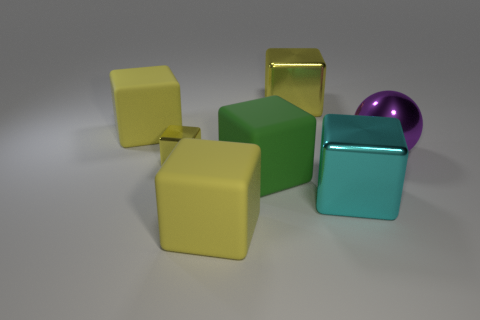How many yellow cubes must be subtracted to get 2 yellow cubes? 2 Subtract all big green matte cubes. How many cubes are left? 5 Add 2 small metallic cubes. How many objects exist? 9 Subtract 1 cubes. How many cubes are left? 5 Subtract all cyan blocks. How many blocks are left? 5 Subtract all cubes. How many objects are left? 1 Subtract all green spheres. How many cyan blocks are left? 1 Add 2 purple metallic spheres. How many purple metallic spheres exist? 3 Subtract 0 red spheres. How many objects are left? 7 Subtract all green cubes. Subtract all brown cylinders. How many cubes are left? 5 